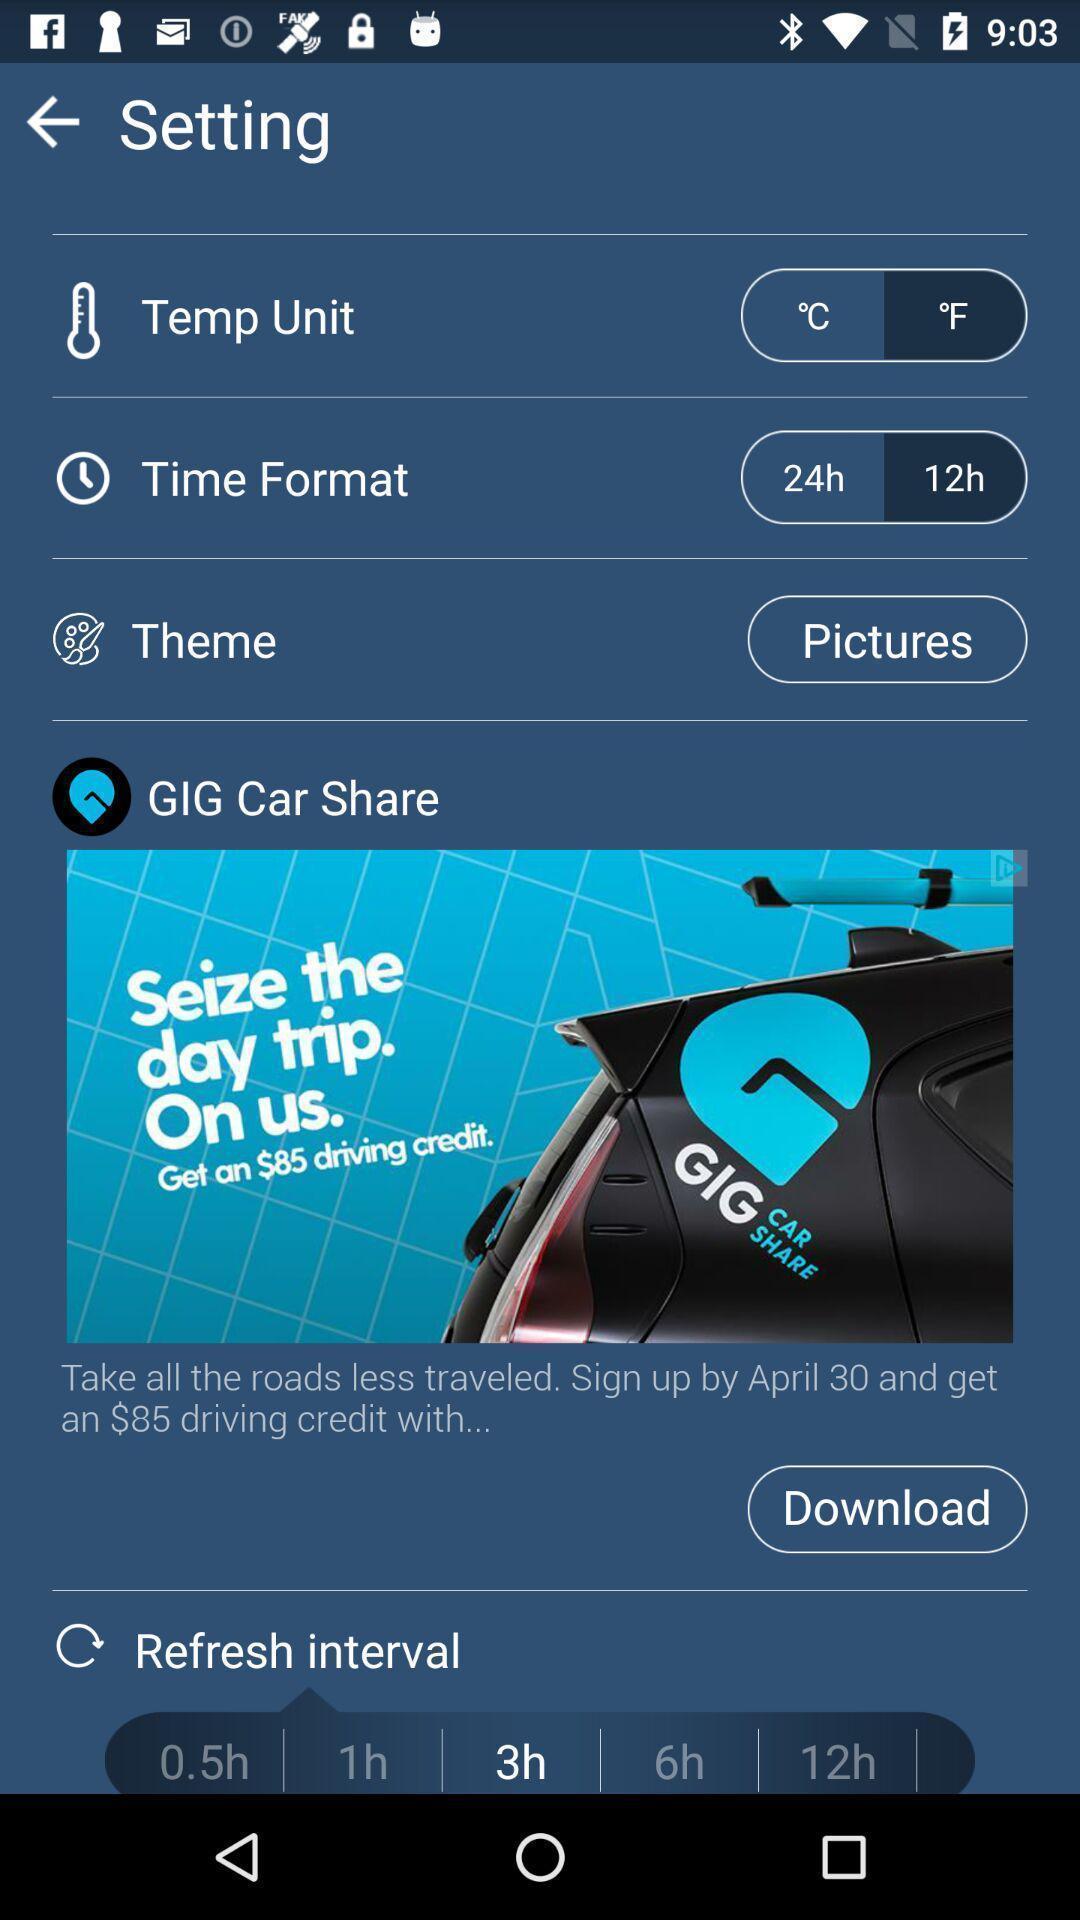Give me a narrative description of this picture. Settings page. 